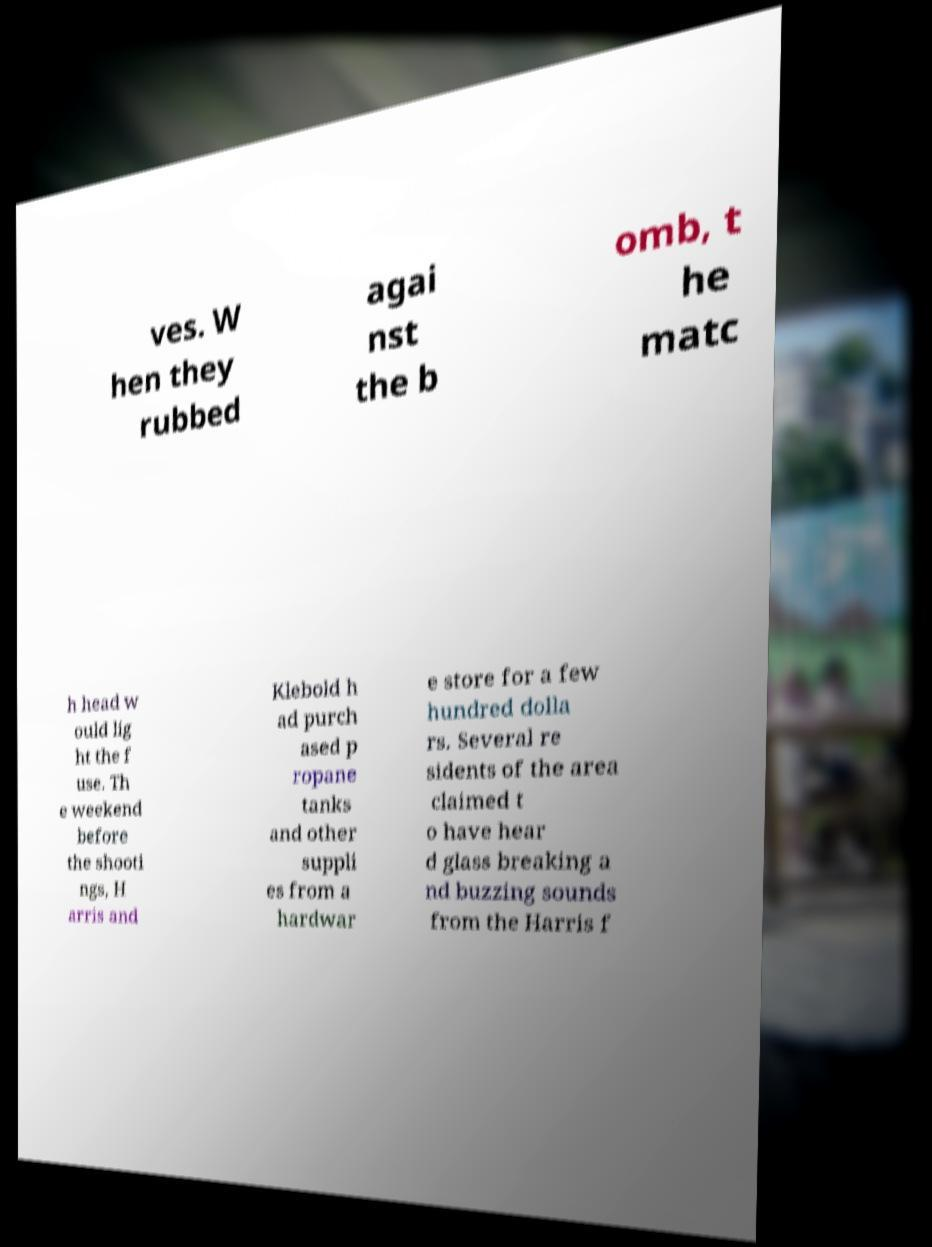Could you assist in decoding the text presented in this image and type it out clearly? ves. W hen they rubbed agai nst the b omb, t he matc h head w ould lig ht the f use. Th e weekend before the shooti ngs, H arris and Klebold h ad purch ased p ropane tanks and other suppli es from a hardwar e store for a few hundred dolla rs. Several re sidents of the area claimed t o have hear d glass breaking a nd buzzing sounds from the Harris f 